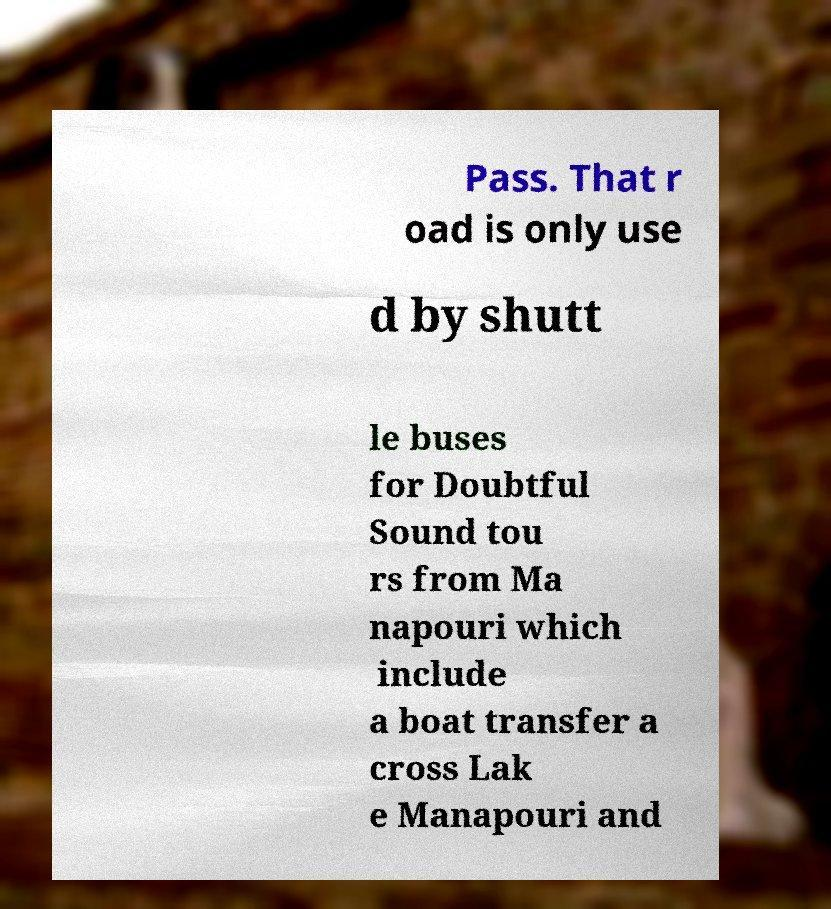Could you extract and type out the text from this image? Pass. That r oad is only use d by shutt le buses for Doubtful Sound tou rs from Ma napouri which include a boat transfer a cross Lak e Manapouri and 